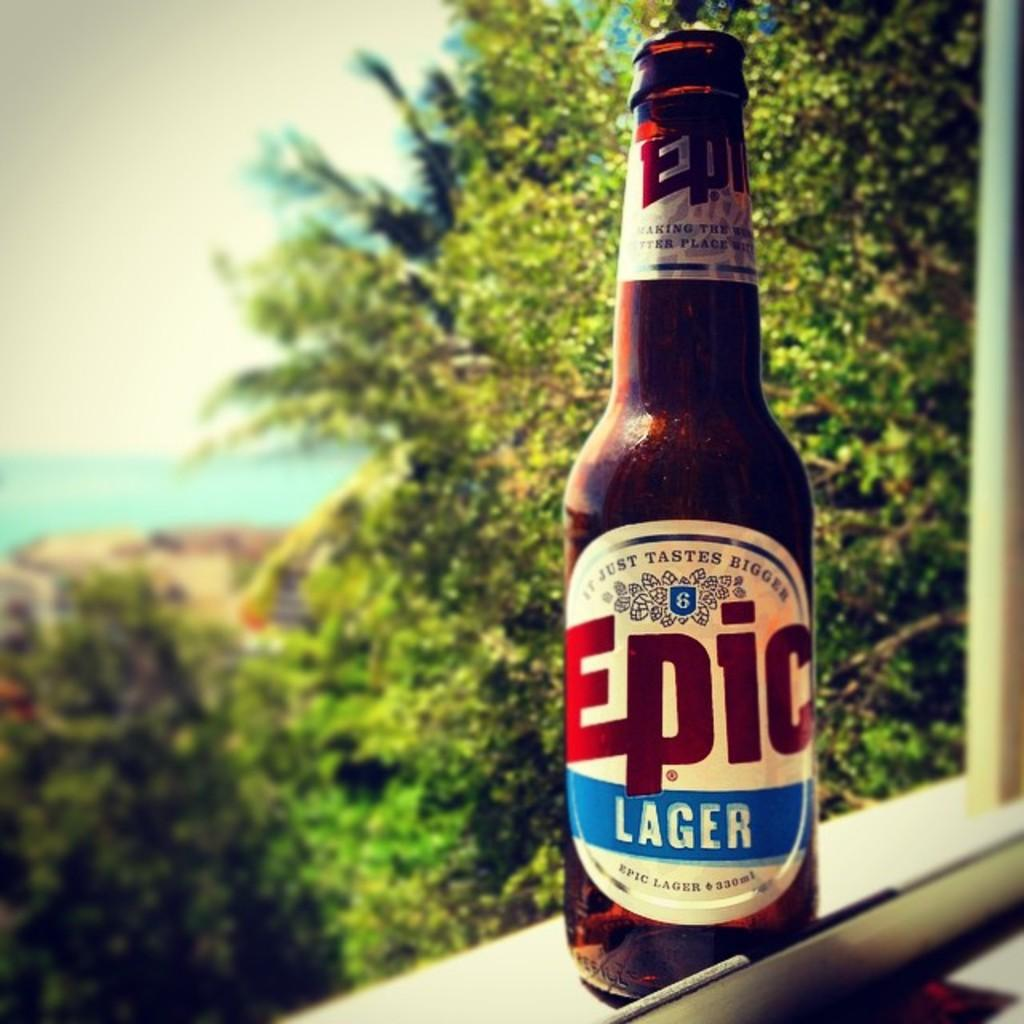<image>
Create a compact narrative representing the image presented. A bottle of Epic lager beer with a red and blue label. 